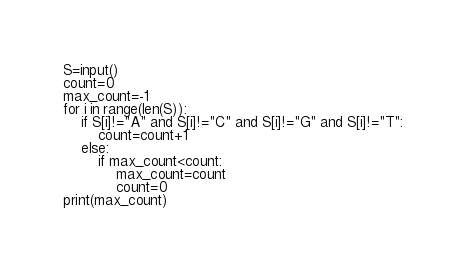<code> <loc_0><loc_0><loc_500><loc_500><_Python_>S=input()
count=0
max_count=-1
for i in range(len(S)):
    if S[i]!="A" and S[i]!="C" and S[i]!="G" and S[i]!="T":
        count=count+1
    else:
        if max_count<count:
            max_count=count
            count=0
print(max_count)</code> 